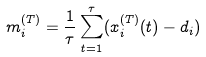Convert formula to latex. <formula><loc_0><loc_0><loc_500><loc_500>m _ { i } ^ { ( T ) } = \frac { 1 } { \tau } \sum _ { t = 1 } ^ { \tau } ( x _ { i } ^ { ( T ) } ( t ) - d _ { i } )</formula> 